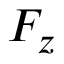Convert formula to latex. <formula><loc_0><loc_0><loc_500><loc_500>F _ { z }</formula> 